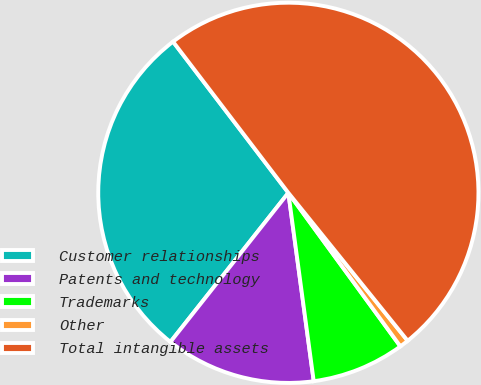Convert chart to OTSL. <chart><loc_0><loc_0><loc_500><loc_500><pie_chart><fcel>Customer relationships<fcel>Patents and technology<fcel>Trademarks<fcel>Other<fcel>Total intangible assets<nl><fcel>28.98%<fcel>12.78%<fcel>7.9%<fcel>0.77%<fcel>49.57%<nl></chart> 